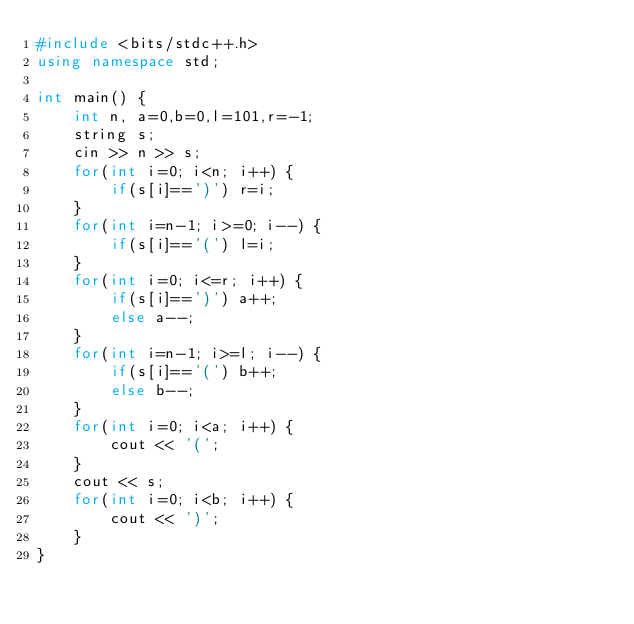Convert code to text. <code><loc_0><loc_0><loc_500><loc_500><_C++_>#include <bits/stdc++.h>
using namespace std;

int main() {
    int n, a=0,b=0,l=101,r=-1;
    string s;
    cin >> n >> s;
    for(int i=0; i<n; i++) {
        if(s[i]==')') r=i;
    }
    for(int i=n-1; i>=0; i--) {
        if(s[i]=='(') l=i;
    }
    for(int i=0; i<=r; i++) {
        if(s[i]==')') a++;
        else a--;
    }
    for(int i=n-1; i>=l; i--) {
        if(s[i]=='(') b++;
        else b--;
    }
    for(int i=0; i<a; i++) {
        cout << '(';
    }
    cout << s;
    for(int i=0; i<b; i++) {
        cout << ')';
    }
}
</code> 